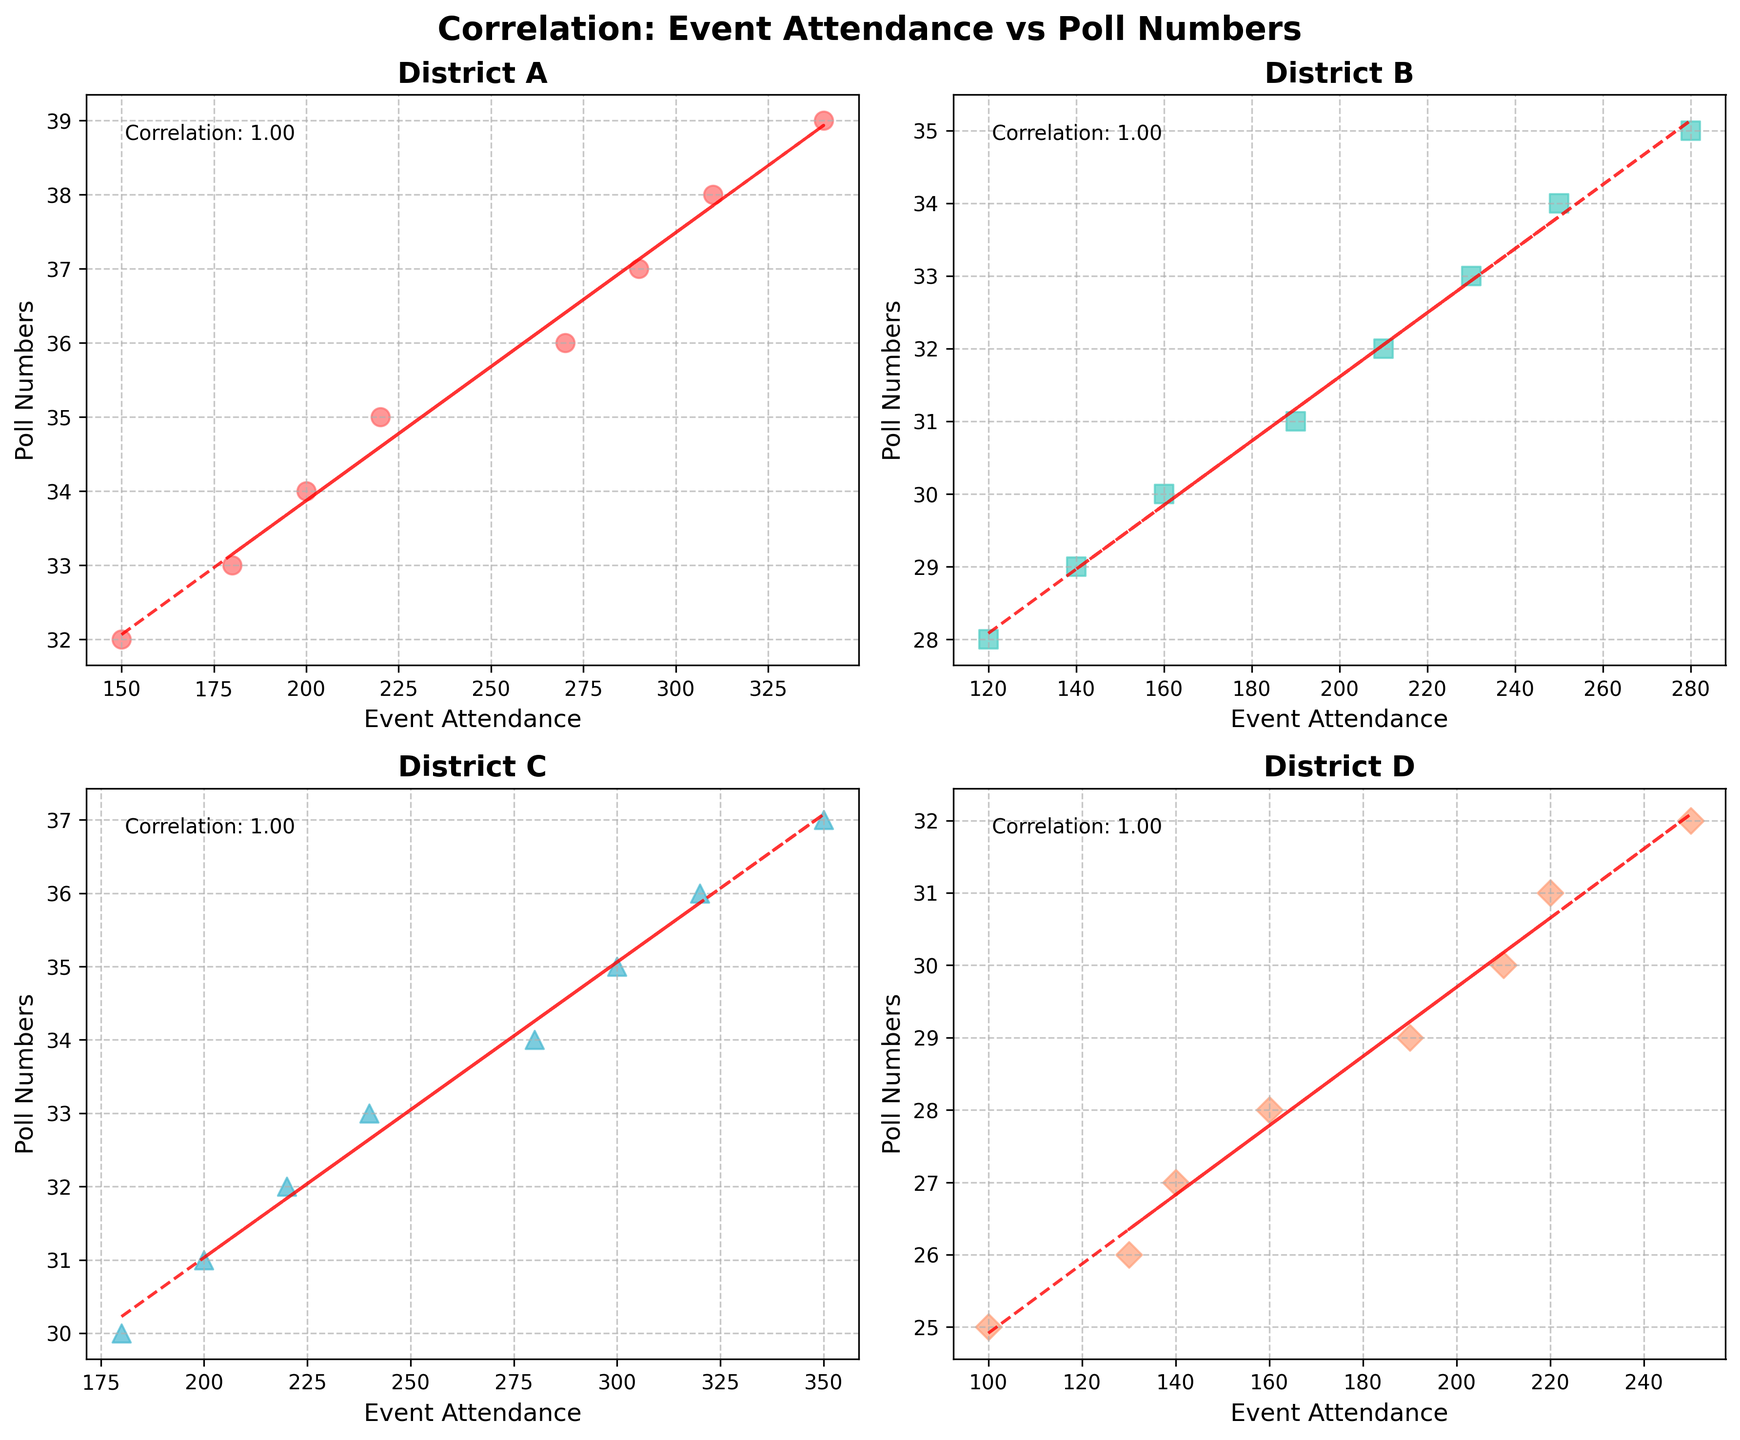What is the correlation coefficient for District A? The subplot for District A shows an annotated correlation coefficient. Locate it in the subplot and state the value.
Answer: 0.97 Which district shows the highest correlation between event attendance and poll numbers? Compare the annotated correlation coefficients for each district and identify the highest one.
Answer: District A What are the event attendance and poll numbers that correspond to the highest point in District B? Locate the highest point in the District B subplot and read the respective x (event attendance) and y (poll numbers) values directly from the axes.
Answer: 280, 35 Which district has the lowest correlation between event attendance and poll numbers? Compare the annotated correlation coefficients for each district and identify the lowest one.
Answer: District D How does the trend line in District C compare with that in District D? Observe the slopes and y-intercepts of the trend lines in both District C and District D subplots. Describe their differences.
Answer: District C has a steeper trend line than District D What is the range of event attendance values for District C? Identify the minimum and maximum x-axis values for event attendance in the District C subplot and state the range.
Answer: 180 to 350 What is the difference in poll numbers between the highest-attended events in District A and District B? Identify the y-axis poll number values corresponding to the highest x-axis event attendance values in both District A and District B, and calculate the difference.
Answer: 39 - 35 = 4 Do any of the districts show a negative correlation between event attendance and poll numbers? Check the annotated correlation coefficients for each subplot; negative values indicate a negative correlation. Confirm if any are negative.
Answer: No Which district has the most dispersed data points? Compare the spread of data points in each subplot. The district with the data points spread out the most widely on both axes has the highest dispersion.
Answer: District D What visual marker and color represent District C? Observe the marker shapes and colors used for District C points in the subplot.
Answer: Triangle and blue 